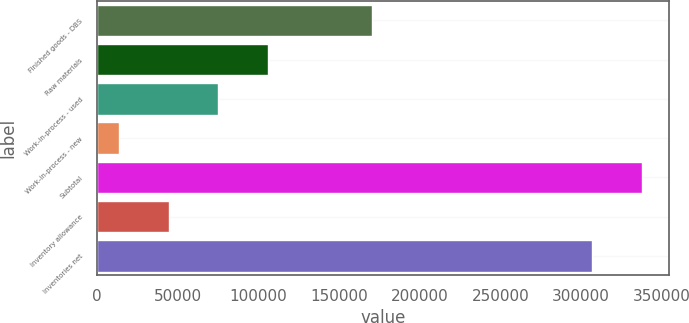Convert chart to OTSL. <chart><loc_0><loc_0><loc_500><loc_500><bar_chart><fcel>Finished goods - DBS<fcel>Raw materials<fcel>Work-in-process - used<fcel>Work-in-process - new<fcel>Subtotal<fcel>Inventory allowance<fcel>Inventories net<nl><fcel>170463<fcel>105978<fcel>75167.6<fcel>13546<fcel>337726<fcel>44356.8<fcel>306915<nl></chart> 